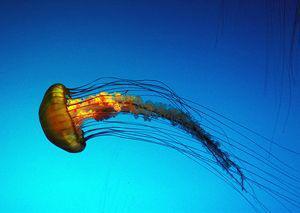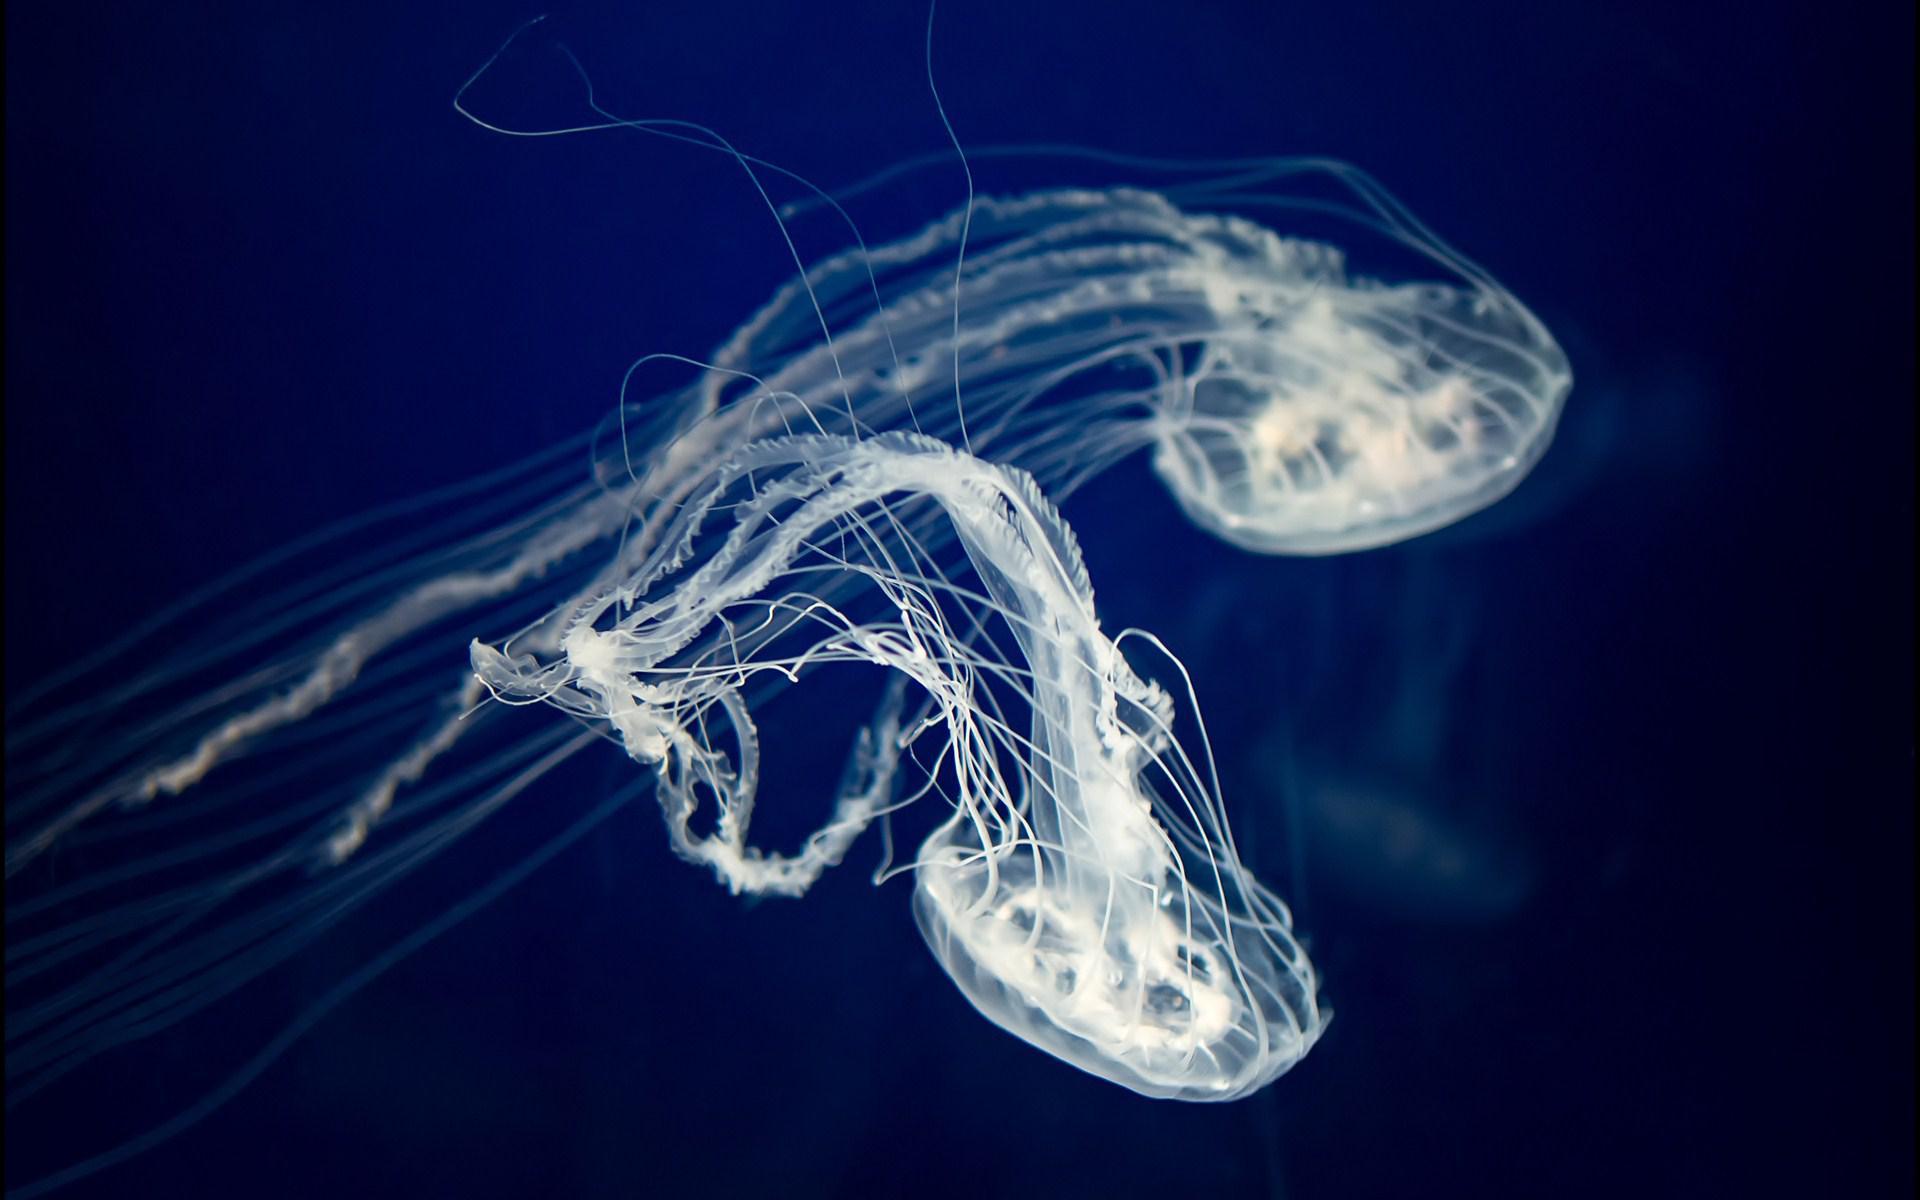The first image is the image on the left, the second image is the image on the right. Examine the images to the left and right. Is the description "There are pale pink jellyfish with a clear blue background" accurate? Answer yes or no. No. 